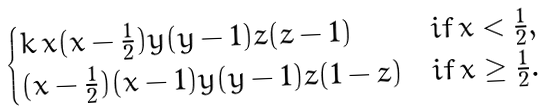<formula> <loc_0><loc_0><loc_500><loc_500>\begin{cases} k \, x ( x - \frac { 1 } { 2 } ) y ( y - 1 ) z ( z - 1 ) & i f \, x < \frac { 1 } { 2 } , \\ ( x - \frac { 1 } { 2 } ) ( x - 1 ) y ( y - 1 ) z ( 1 - z ) & i f \, x \geq \frac { 1 } { 2 } . \\ \end{cases}</formula> 